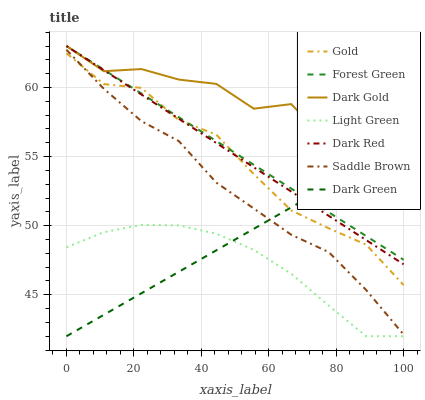Does Light Green have the minimum area under the curve?
Answer yes or no. Yes. Does Dark Gold have the maximum area under the curve?
Answer yes or no. Yes. Does Dark Red have the minimum area under the curve?
Answer yes or no. No. Does Dark Red have the maximum area under the curve?
Answer yes or no. No. Is Forest Green the smoothest?
Answer yes or no. Yes. Is Dark Gold the roughest?
Answer yes or no. Yes. Is Dark Red the smoothest?
Answer yes or no. No. Is Dark Red the roughest?
Answer yes or no. No. Does Light Green have the lowest value?
Answer yes or no. Yes. Does Dark Red have the lowest value?
Answer yes or no. No. Does Forest Green have the highest value?
Answer yes or no. Yes. Does Light Green have the highest value?
Answer yes or no. No. Is Dark Green less than Dark Gold?
Answer yes or no. Yes. Is Dark Gold greater than Dark Green?
Answer yes or no. Yes. Does Dark Green intersect Saddle Brown?
Answer yes or no. Yes. Is Dark Green less than Saddle Brown?
Answer yes or no. No. Is Dark Green greater than Saddle Brown?
Answer yes or no. No. Does Dark Green intersect Dark Gold?
Answer yes or no. No. 